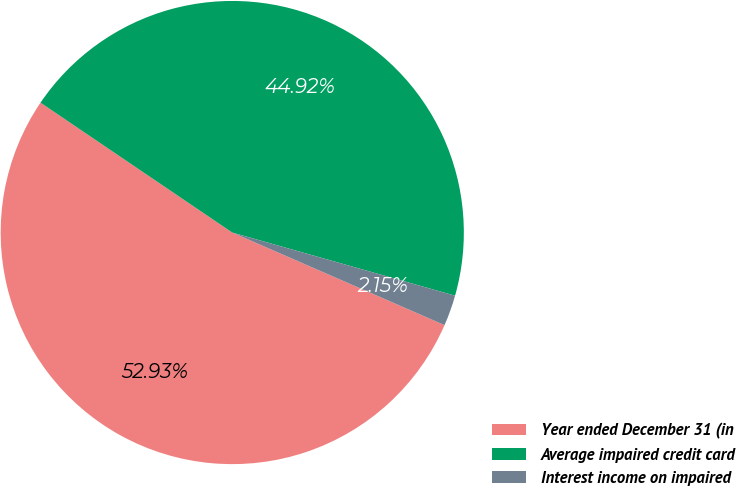Convert chart. <chart><loc_0><loc_0><loc_500><loc_500><pie_chart><fcel>Year ended December 31 (in<fcel>Average impaired credit card<fcel>Interest income on impaired<nl><fcel>52.93%<fcel>44.92%<fcel>2.15%<nl></chart> 